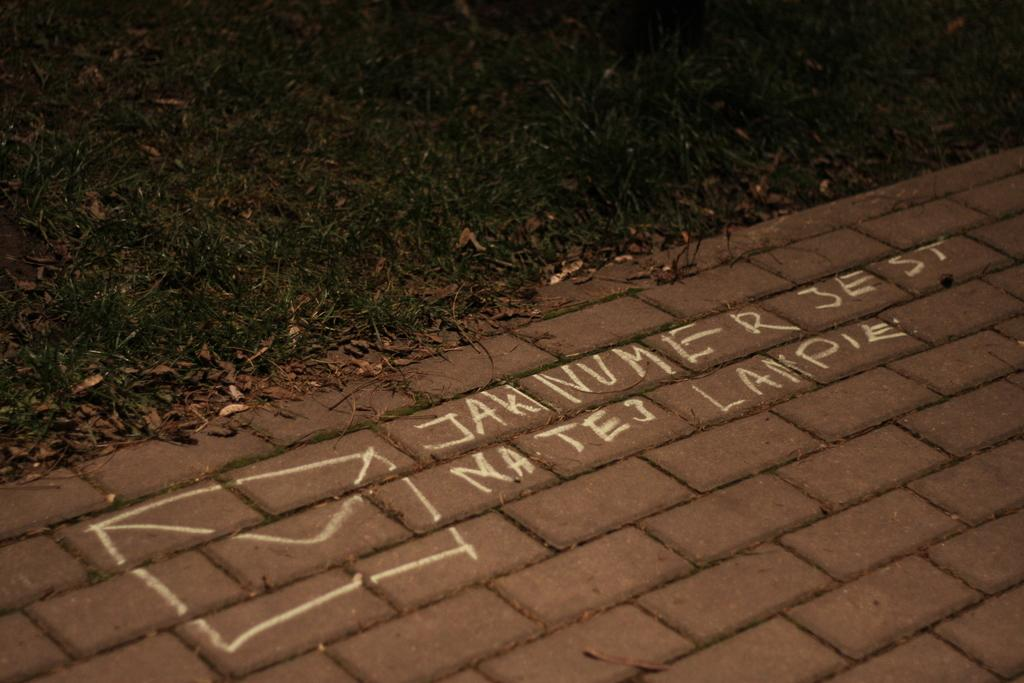Where was the picture taken? The picture was taken outside. What can be seen in the foreground of the image? There is text on the pavement in the foreground. What type of vegetation is visible in the background? Green grass is visible in the background. What else can be seen on the ground in the background? Dry leaves are lying on the ground in the background. What type of structure is visible in the image? There is no structure visible in the image; it primarily features text on the pavement, green grass, and dry leaves. 